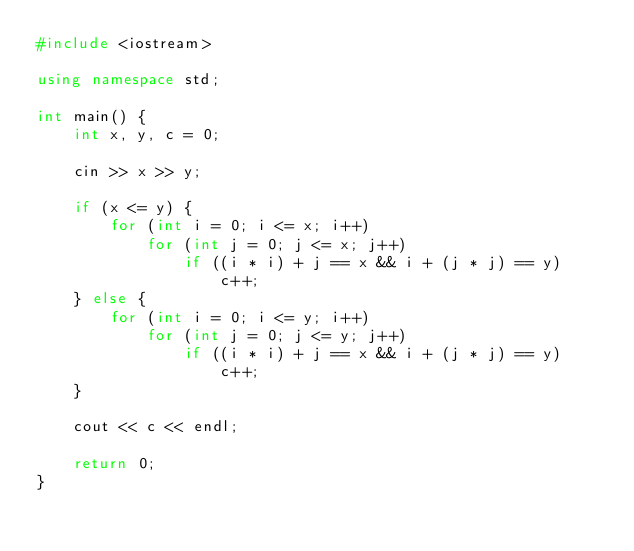<code> <loc_0><loc_0><loc_500><loc_500><_C++_>#include <iostream>

using namespace std;

int main() {
	int x, y, c = 0;

	cin >> x >> y;

	if (x <= y) {
		for (int i = 0; i <= x; i++)
			for (int j = 0; j <= x; j++)
				if ((i * i) + j == x && i + (j * j) == y)
					c++;
	} else {
		for (int i = 0; i <= y; i++)
			for (int j = 0; j <= y; j++)
				if ((i * i) + j == x && i + (j * j) == y)
					c++;
	}

	cout << c << endl;

	return 0;
}
</code> 